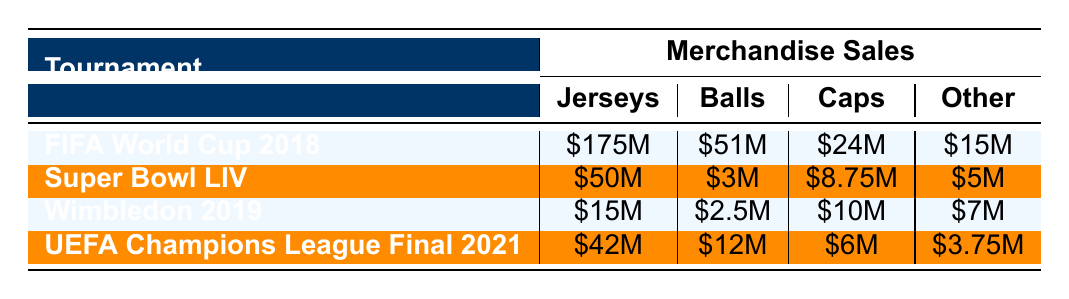What was the total revenue from merchandise sales during the FIFA World Cup 2018? The total revenue from merchandise sales includes jerseys ($175M), footballs ($51M), caps ($24M), and scarves ($15M). Adding these amounts together gives us: 175 + 51 + 24 + 15 = 265 million dollars.
Answer: 265 million dollars Which tournament had the highest revenue from caps sales? The sales from caps during each tournament are as follows: FIFA World Cup 2018 ($24M), Super Bowl LIV ($8.75M), Wimbledon 2019 ($10M), UEFA Champions League Final 2021 ($6M). The highest amount is $24M from the FIFA World Cup 2018.
Answer: FIFA World Cup 2018 Is it true that Super Bowl LIV generated more revenue from jerseys than Wimbledon 2019? Super Bowl LIV generated $50M from jerseys while Wimbledon 2019 generated $15M. Since $50M is greater than $15M, the statement is true.
Answer: Yes What is the average total revenue from merchandise sales across the four tournaments? To find the average total revenue, we first determine the total revenue for each tournament: FIFA World Cup 2018 ($265M), Super Bowl LIV ($73.75M), Wimbledon 2019 ($32.5M), and UEFA Champions League Final 2021 ($61M). Adding these gives us a total of $432.25M, and dividing by 4 results in an average of $108.0625M.
Answer: 108.0625 million dollars Which tournament had the lowest total revenue from merchandise sales? The total revenue amounts are as follows: FIFA World Cup 2018 ($265M), Super Bowl LIV ($73.75M), Wimbledon 2019 ($32.5M), and UEFA Champions League Final 2021 ($61M). The lowest amount is $32.5M from Wimbledon 2019.
Answer: Wimbledon 2019 What is the difference in total revenue from football sales between FIFA World Cup 2018 and UEFA Champions League Final 2021? The total revenue from football sales is $51M for the FIFA World Cup 2018 and $12M for the UEFA Champions League Final 2021. The difference is $51M - $12M = $39M.
Answer: 39 million dollars Did the FIFA World Cup 2018 sell more jerseys than the combined total of jerseys sold in Super Bowl LIV and UEFA Champions League Final 2021? FIFA World Cup 2018 sold 2,500,000 jerseys, Super Bowl LIV sold 500,000, and UEFA Champions League Final 2021 sold 600,000. The total for Super Bowl LIV and UEFA Champions League Final 2021 is 500,000 + 600,000 = 1,100,000. Since 2,500,000 is greater than 1,100,000, the statement is true.
Answer: Yes Which merchandise category generated the highest overall revenue during all tournaments? The revenue from each category across all tournaments is: Jerseys ($265M), Footballs ($78.75M), Caps ($48.75M), and Other ($30.75M). The highest overall revenue is from Jerseys at $265M.
Answer: Jerseys 